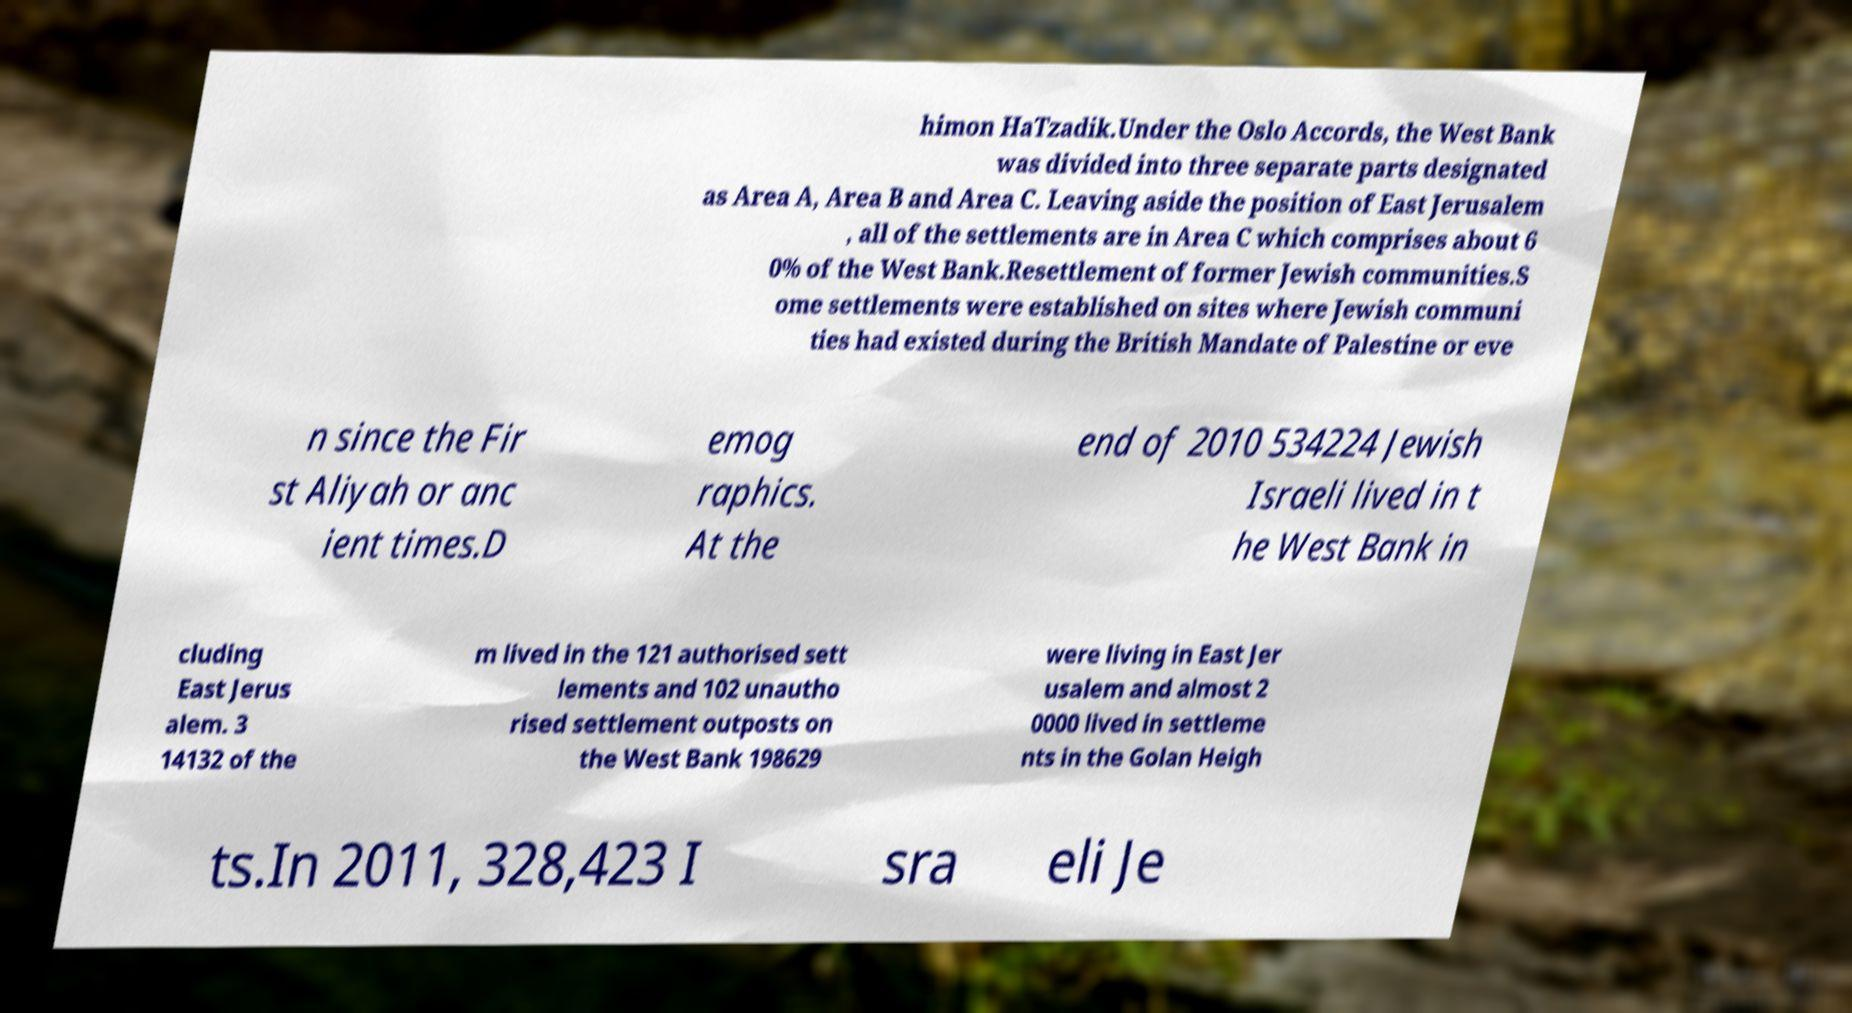I need the written content from this picture converted into text. Can you do that? himon HaTzadik.Under the Oslo Accords, the West Bank was divided into three separate parts designated as Area A, Area B and Area C. Leaving aside the position of East Jerusalem , all of the settlements are in Area C which comprises about 6 0% of the West Bank.Resettlement of former Jewish communities.S ome settlements were established on sites where Jewish communi ties had existed during the British Mandate of Palestine or eve n since the Fir st Aliyah or anc ient times.D emog raphics. At the end of 2010 534224 Jewish Israeli lived in t he West Bank in cluding East Jerus alem. 3 14132 of the m lived in the 121 authorised sett lements and 102 unautho rised settlement outposts on the West Bank 198629 were living in East Jer usalem and almost 2 0000 lived in settleme nts in the Golan Heigh ts.In 2011, 328,423 I sra eli Je 